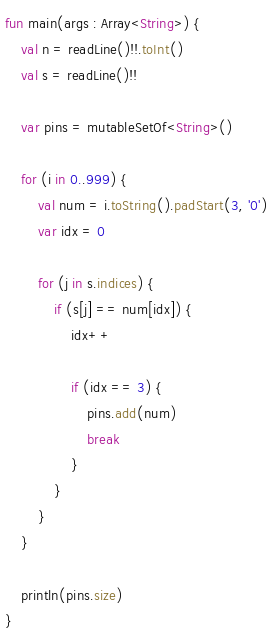Convert code to text. <code><loc_0><loc_0><loc_500><loc_500><_Kotlin_>fun main(args : Array<String>) {
    val n = readLine()!!.toInt()
    val s = readLine()!!

    var pins = mutableSetOf<String>()

    for (i in 0..999) {
        val num = i.toString().padStart(3, '0')
        var idx = 0

        for (j in s.indices) {
            if (s[j] == num[idx]) {
                idx++

                if (idx == 3) {
                    pins.add(num)
                    break
                }
            }
        }
    }

    println(pins.size)
}</code> 